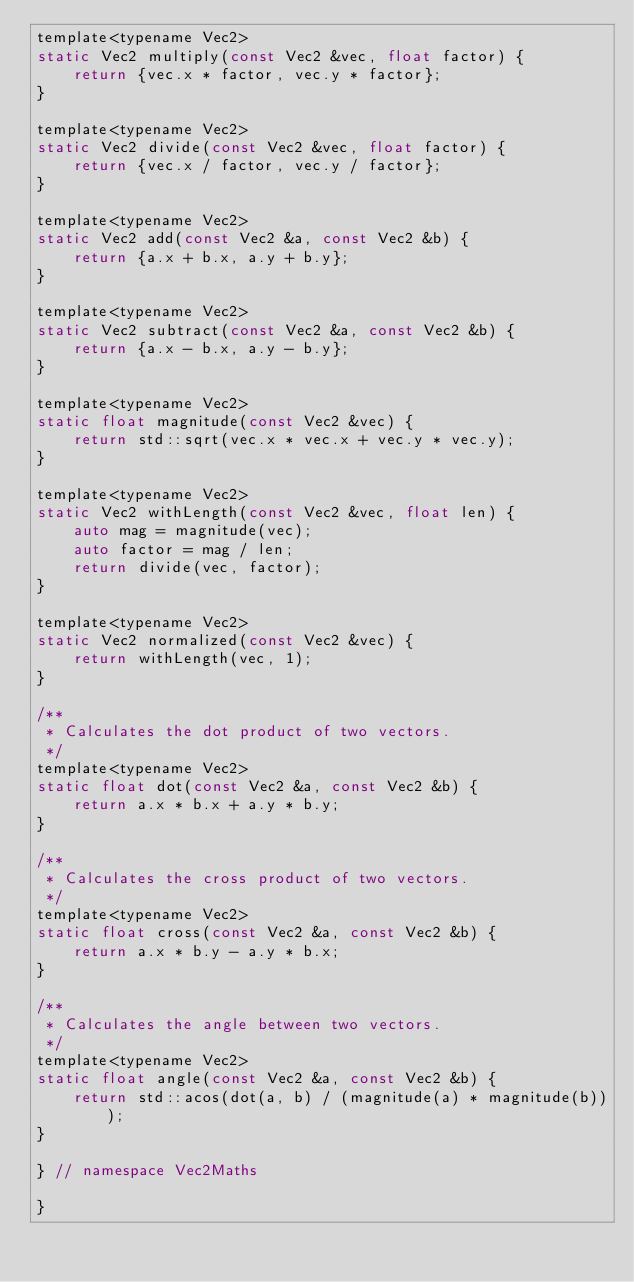Convert code to text. <code><loc_0><loc_0><loc_500><loc_500><_C_>template<typename Vec2>
static Vec2 multiply(const Vec2 &vec, float factor) {
	return {vec.x * factor, vec.y * factor};
}

template<typename Vec2>
static Vec2 divide(const Vec2 &vec, float factor) {
	return {vec.x / factor, vec.y / factor};
}

template<typename Vec2>
static Vec2 add(const Vec2 &a, const Vec2 &b) {
	return {a.x + b.x, a.y + b.y};
}

template<typename Vec2>
static Vec2 subtract(const Vec2 &a, const Vec2 &b) {
	return {a.x - b.x, a.y - b.y};
}

template<typename Vec2>
static float magnitude(const Vec2 &vec) {
	return std::sqrt(vec.x * vec.x + vec.y * vec.y);
}

template<typename Vec2>
static Vec2 withLength(const Vec2 &vec, float len) {
	auto mag = magnitude(vec);
	auto factor = mag / len;
	return divide(vec, factor);
}

template<typename Vec2>
static Vec2 normalized(const Vec2 &vec) {
	return withLength(vec, 1);
}

/**
 * Calculates the dot product of two vectors.
 */
template<typename Vec2>
static float dot(const Vec2 &a, const Vec2 &b) {
	return a.x * b.x + a.y * b.y;
}

/**
 * Calculates the cross product of two vectors.
 */
template<typename Vec2>
static float cross(const Vec2 &a, const Vec2 &b) {
	return a.x * b.y - a.y * b.x;
}

/**
 * Calculates the angle between two vectors.
 */
template<typename Vec2>
static float angle(const Vec2 &a, const Vec2 &b) {
	return std::acos(dot(a, b) / (magnitude(a) * magnitude(b)));
}

} // namespace Vec2Maths

}</code> 